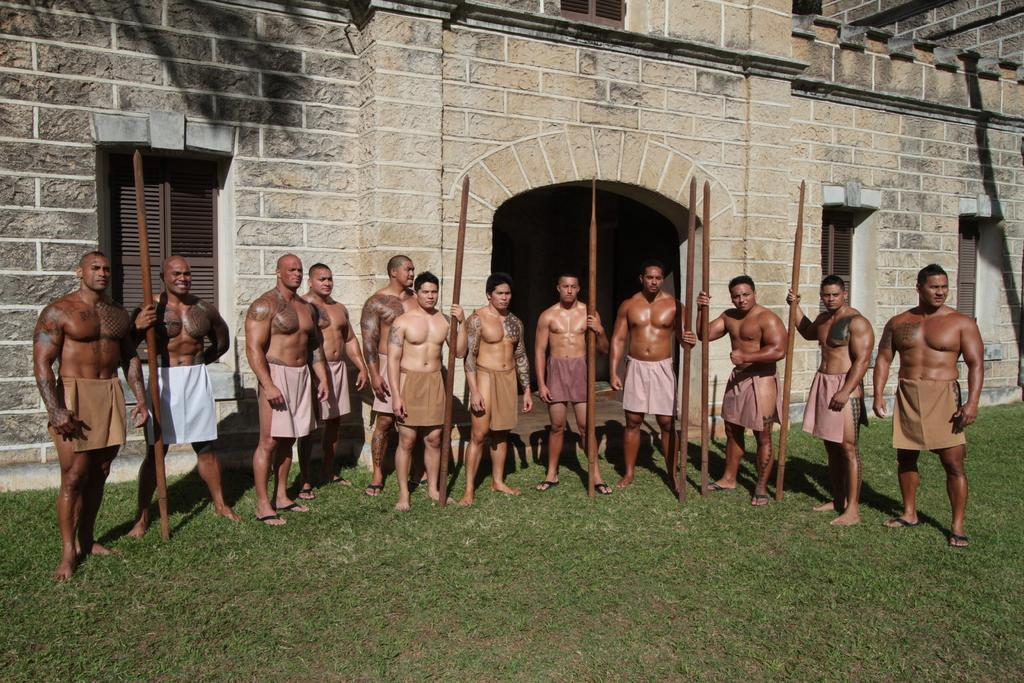What are the people in the image doing? The persons in the image are standing on the ground. What is the surface they are standing on? The ground is covered with grass. What can be seen in the background of the image? There is a building in the background of the image. How does the comfort of the plastic chairs affect the people in the image? There are no plastic chairs present in the image, so the comfort of plastic chairs cannot affect the people in the image. 